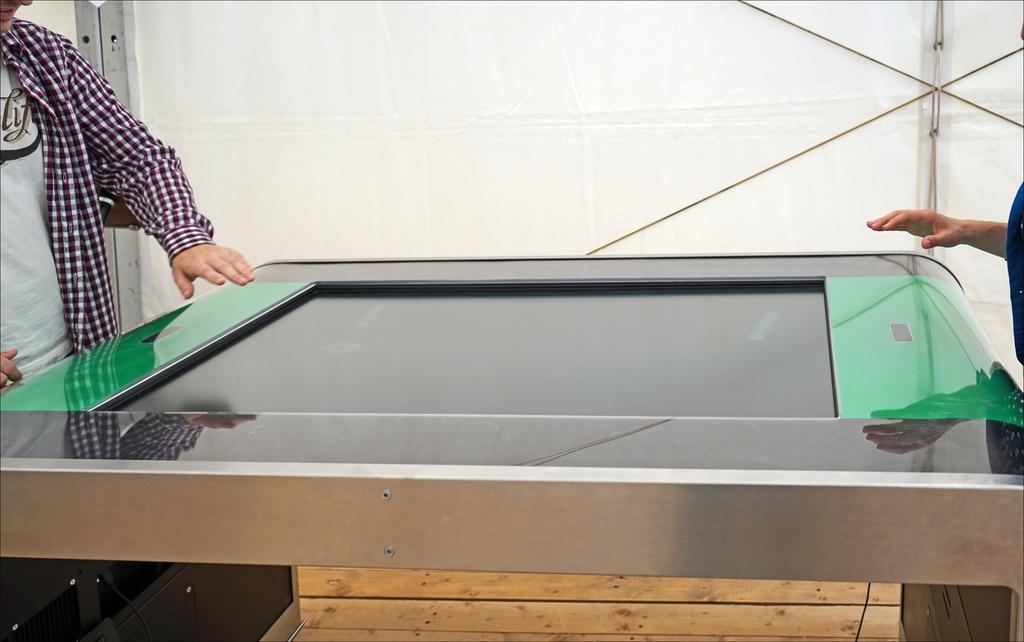Please provide a concise description of this image. In this image there is a table, people, wooden floor and wall. In-front of them there is a table. 